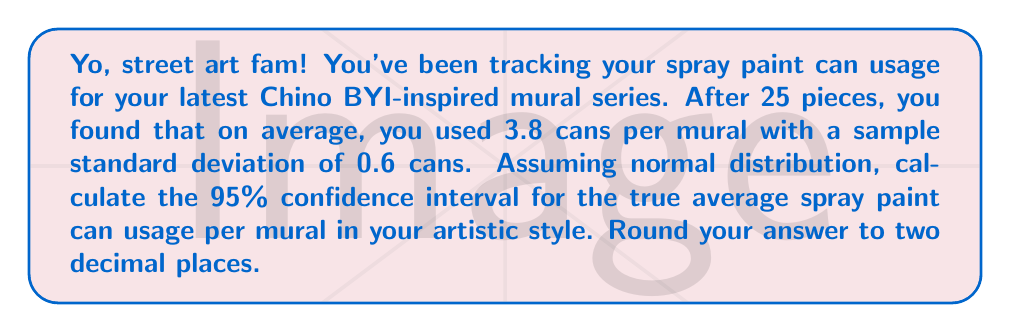What is the answer to this math problem? Alright, let's break this down step-by-step:

1) We're dealing with a confidence interval for a population mean with unknown population standard deviation. We'll use the t-distribution.

2) Given information:
   - Sample size: $n = 25$
   - Sample mean: $\bar{x} = 3.8$ cans
   - Sample standard deviation: $s = 0.6$ cans
   - Confidence level: 95%

3) The formula for the confidence interval is:

   $$\bar{x} \pm t_{\alpha/2} \cdot \frac{s}{\sqrt{n}}$$

4) For a 95% confidence interval, $\alpha = 0.05$, and $\alpha/2 = 0.025$

5) Degrees of freedom: $df = n - 1 = 25 - 1 = 24$

6) From the t-distribution table, $t_{0.025, 24} \approx 2.064$

7) Calculate the margin of error:

   $$\text{Margin of Error} = t_{0.025, 24} \cdot \frac{s}{\sqrt{n}} = 2.064 \cdot \frac{0.6}{\sqrt{25}} \approx 0.2477$$

8) Calculate the confidence interval:

   Lower bound: $3.8 - 0.2477 \approx 3.5523$
   Upper bound: $3.8 + 0.2477 \approx 4.0477$

9) Rounding to two decimal places:

   Lower bound: $3.55$
   Upper bound: $4.05$
Answer: (3.55, 4.05) 